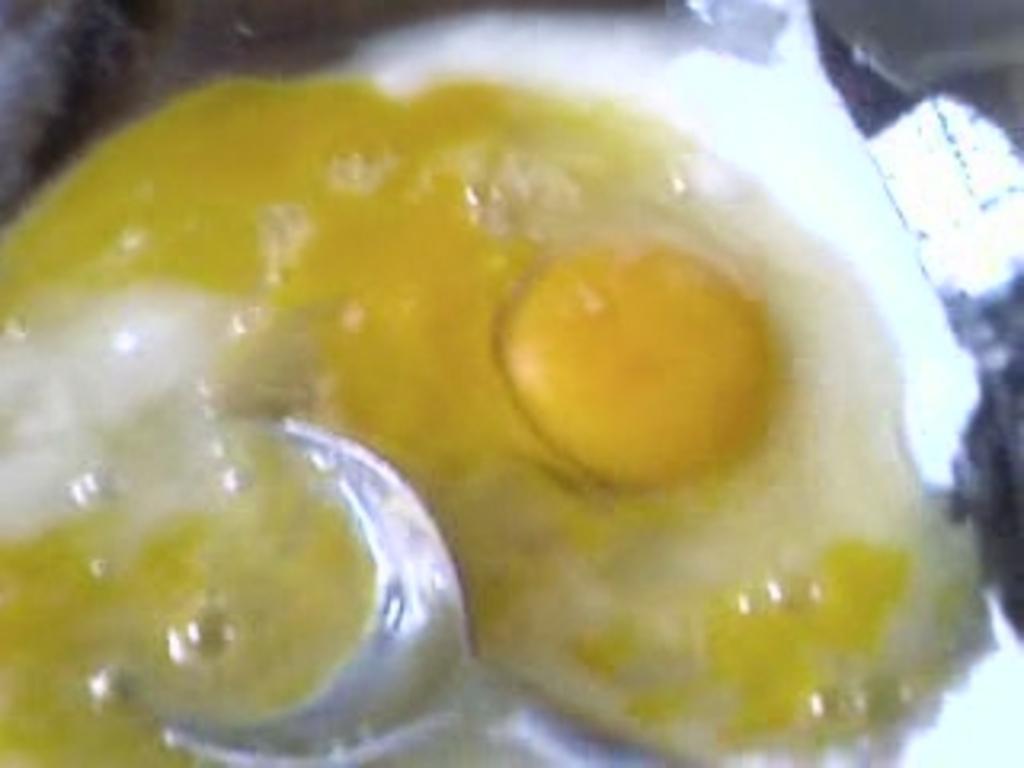Please provide a concise description of this image. In the center of the image we can see food and spoon. 